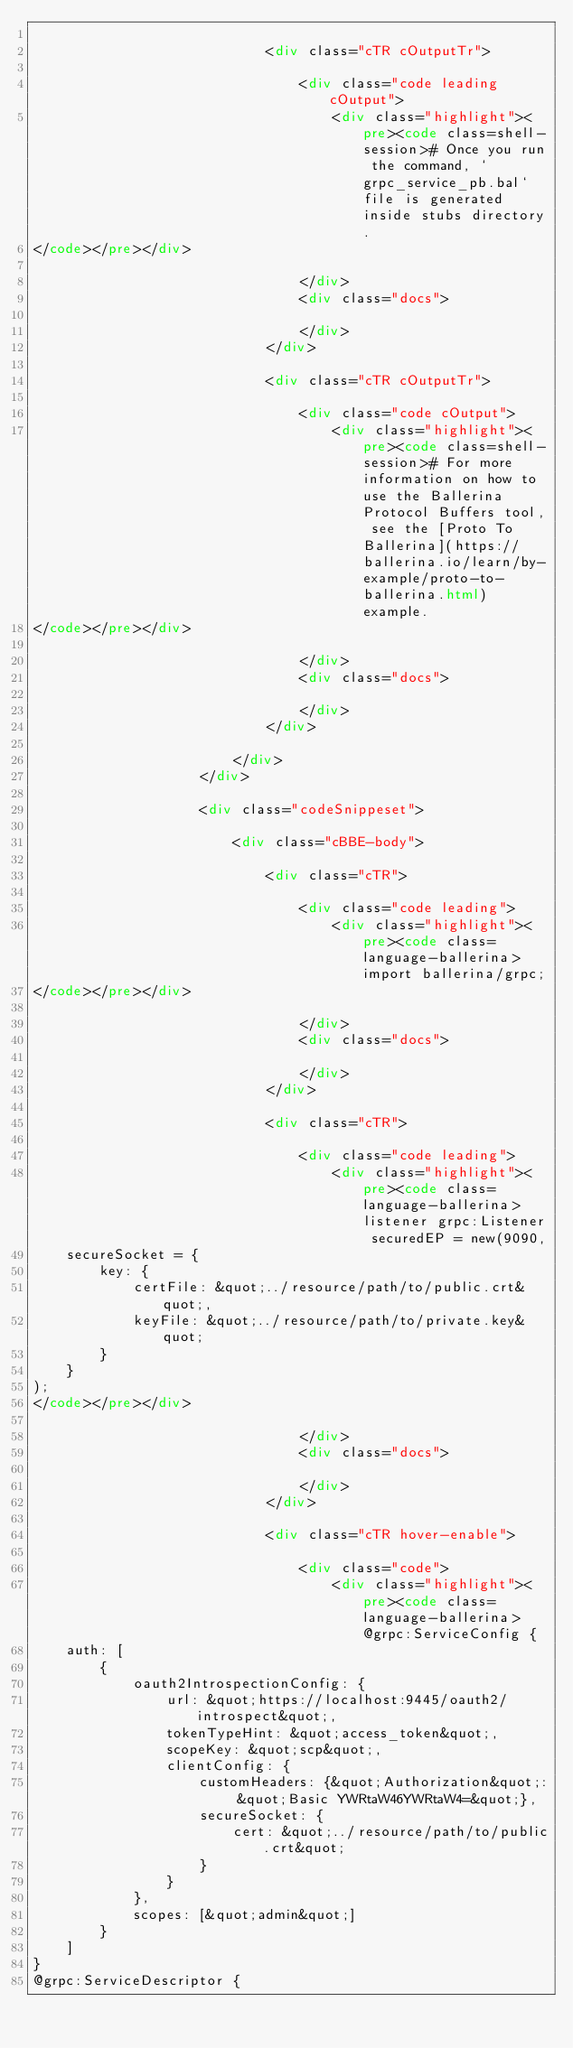<code> <loc_0><loc_0><loc_500><loc_500><_HTML_>                            
                            <div class="cTR cOutputTr">

                                <div class="code leading cOutput">
                                    <div class="highlight"><pre><code class=shell-session># Once you run the command, `grpc_service_pb.bal` file is generated inside stubs directory.
</code></pre></div>

                                </div>
                                <div class="docs">
                                    
                                </div>
                            </div>
                            
                            <div class="cTR cOutputTr">

                                <div class="code cOutput">
                                    <div class="highlight"><pre><code class=shell-session># For more information on how to use the Ballerina Protocol Buffers tool, see the [Proto To Ballerina](https://ballerina.io/learn/by-example/proto-to-ballerina.html) example.
</code></pre></div>

                                </div>
                                <div class="docs">
                                    
                                </div>
                            </div>
                            
                        </div>
                    </div>
                    
                    <div class="codeSnippeset">

                        <div class="cBBE-body">
                            
                            <div class="cTR">

                                <div class="code leading">
                                    <div class="highlight"><pre><code class=language-ballerina>import ballerina/grpc;
</code></pre></div>

                                </div>
                                <div class="docs">
                                    
                                </div>
                            </div>
                            
                            <div class="cTR">

                                <div class="code leading">
                                    <div class="highlight"><pre><code class=language-ballerina>listener grpc:Listener securedEP = new(9090,
    secureSocket = {
        key: {
            certFile: &quot;../resource/path/to/public.crt&quot;,
            keyFile: &quot;../resource/path/to/private.key&quot;
        }
    }
);
</code></pre></div>

                                </div>
                                <div class="docs">
                                    
                                </div>
                            </div>
                            
                            <div class="cTR hover-enable">

                                <div class="code">
                                    <div class="highlight"><pre><code class=language-ballerina>@grpc:ServiceConfig {
    auth: [
        {
            oauth2IntrospectionConfig: {
                url: &quot;https://localhost:9445/oauth2/introspect&quot;,
                tokenTypeHint: &quot;access_token&quot;,
                scopeKey: &quot;scp&quot;,
                clientConfig: {
                    customHeaders: {&quot;Authorization&quot;: &quot;Basic YWRtaW46YWRtaW4=&quot;},
                    secureSocket: {
                        cert: &quot;../resource/path/to/public.crt&quot;
                    }
                }
            },
            scopes: [&quot;admin&quot;]
        }
    ]
}
@grpc:ServiceDescriptor {</code> 